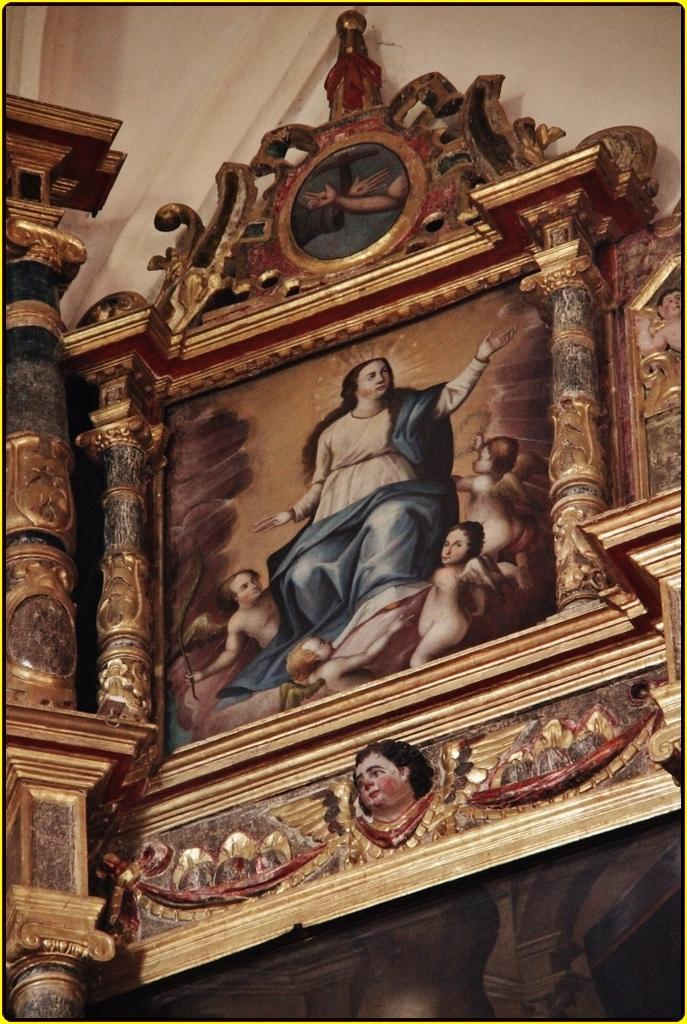What type of structure can be seen in the image? There is a wall in the image. What is attached to the wall in the image? There is a frame in the image. What is depicted within the frame in the image? The depictions of people are visible in the image. What type of trousers are the people wearing in the image? There is no information about the clothing of the people in the image, as it only provides details about the wall, frame, and depictions of people. 